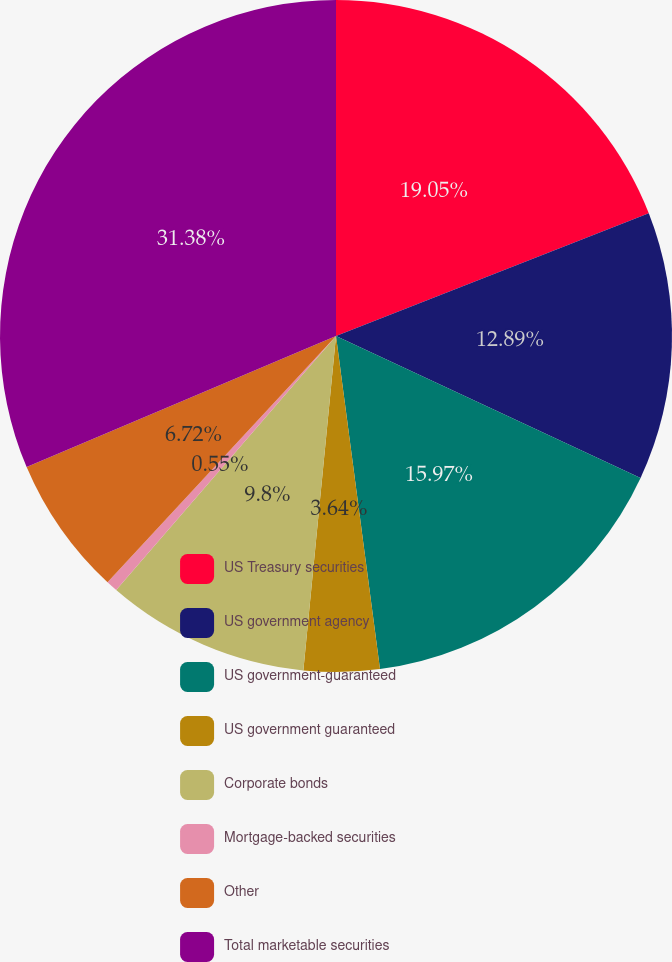<chart> <loc_0><loc_0><loc_500><loc_500><pie_chart><fcel>US Treasury securities<fcel>US government agency<fcel>US government-guaranteed<fcel>US government guaranteed<fcel>Corporate bonds<fcel>Mortgage-backed securities<fcel>Other<fcel>Total marketable securities<nl><fcel>19.05%<fcel>12.89%<fcel>15.97%<fcel>3.64%<fcel>9.8%<fcel>0.55%<fcel>6.72%<fcel>31.38%<nl></chart> 